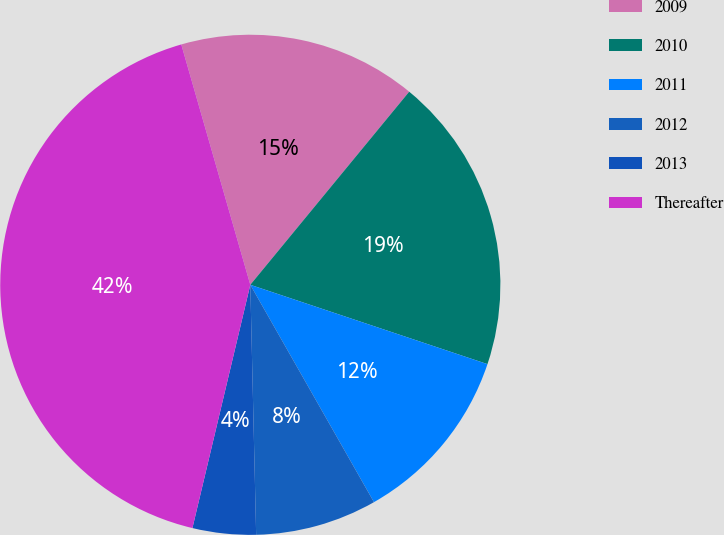Convert chart. <chart><loc_0><loc_0><loc_500><loc_500><pie_chart><fcel>2009<fcel>2010<fcel>2011<fcel>2012<fcel>2013<fcel>Thereafter<nl><fcel>15.41%<fcel>19.18%<fcel>11.63%<fcel>7.86%<fcel>4.09%<fcel>41.83%<nl></chart> 